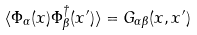Convert formula to latex. <formula><loc_0><loc_0><loc_500><loc_500>\langle \Phi _ { \alpha } ( x ) \Phi _ { \beta } ^ { \dagger } ( x ^ { \prime } ) \rangle = G _ { \alpha \beta } ( x , x ^ { \prime } )</formula> 